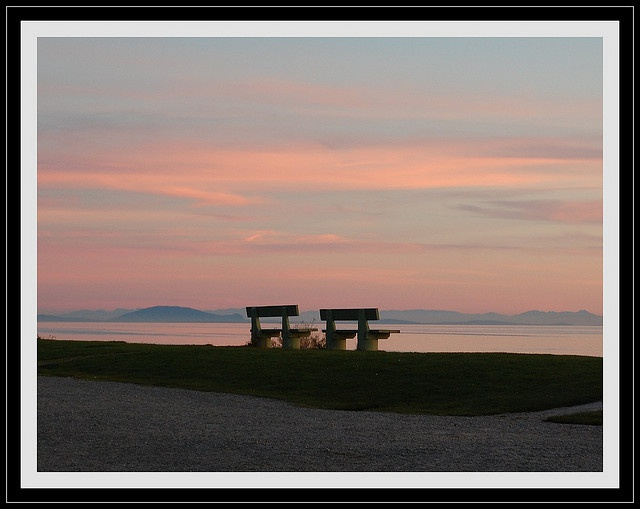Describe the objects in this image and their specific colors. I can see bench in black, gray, and darkgray tones and bench in black, olive, and gray tones in this image. 